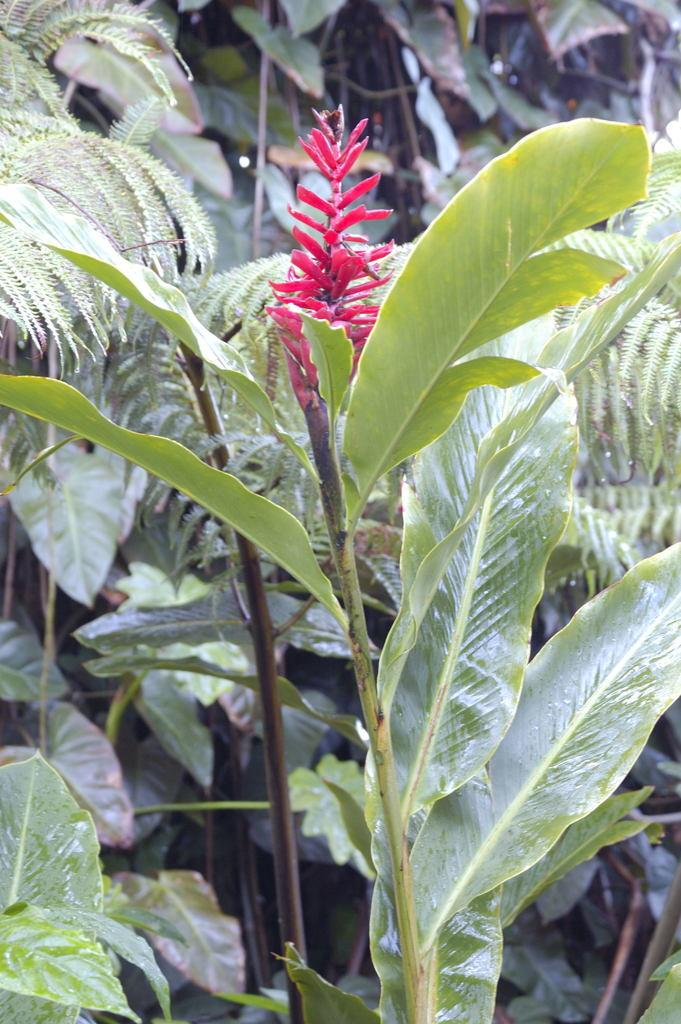What type of flower is present in the image? There is a red color flower in the image. What color are the leaves in the image? There are green color leaves in the image. Where is the stove located in the image? There is no stove present in the image. What type of fruit can be seen hanging from the leaves in the image? There is no fruit visible in the image; only a red flower and green leaves are present. 